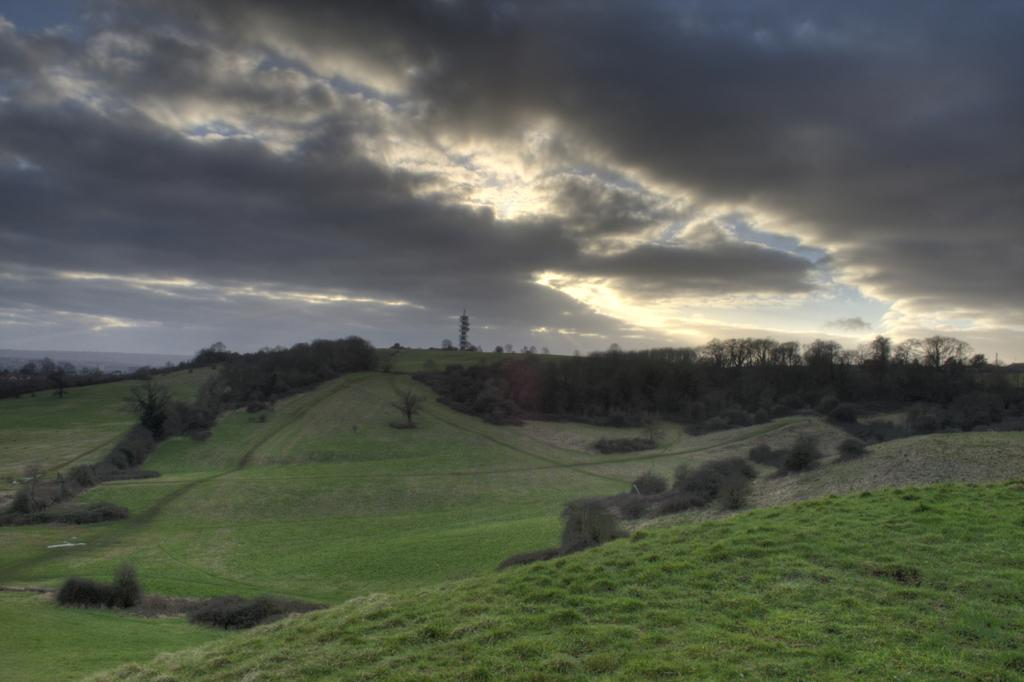What type of vegetation is present in the image? There is grass in the image. What other natural elements can be seen in the image? There are trees in the image. How would you describe the sky in the image? The sky is cloudy in the image. How many robins can be seen in the image? There are no robins present in the image. What is the value of the baby in the image? There is no baby present in the image, so it is not possible to determine its value. 